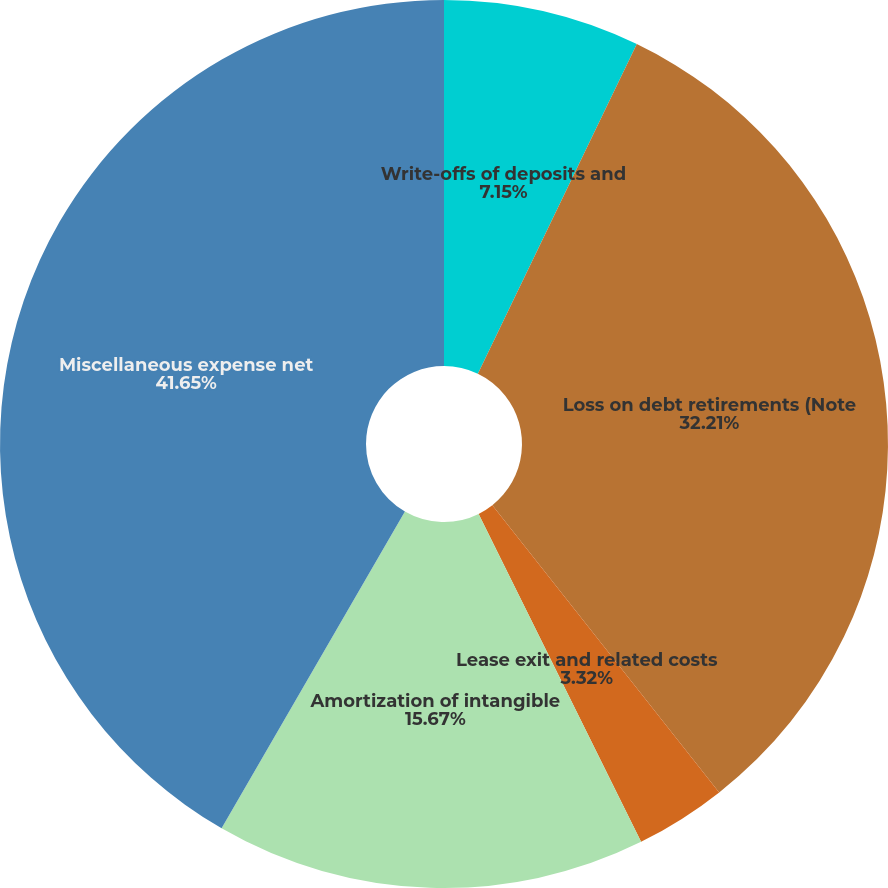Convert chart. <chart><loc_0><loc_0><loc_500><loc_500><pie_chart><fcel>Write-offs of deposits and<fcel>Loss on debt retirements (Note<fcel>Lease exit and related costs<fcel>Amortization of intangible<fcel>Miscellaneous expense net<nl><fcel>7.15%<fcel>32.21%<fcel>3.32%<fcel>15.67%<fcel>41.65%<nl></chart> 